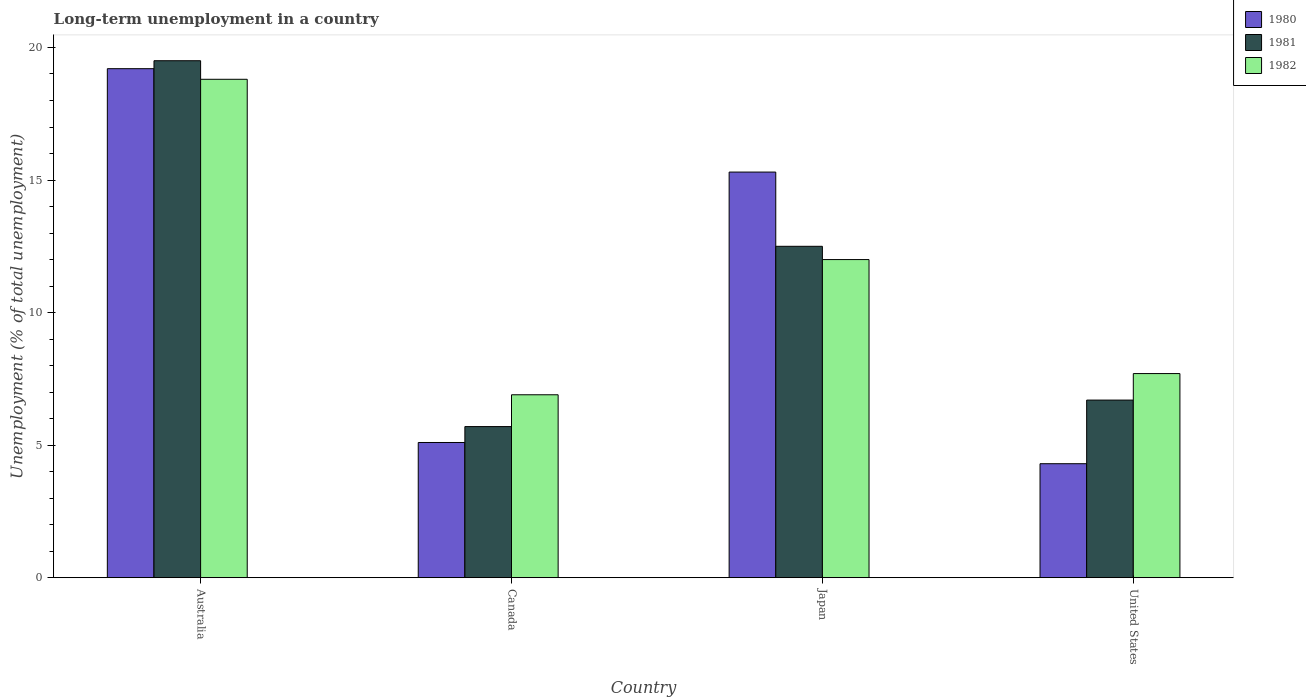How many groups of bars are there?
Your answer should be compact. 4. Are the number of bars on each tick of the X-axis equal?
Offer a terse response. Yes. How many bars are there on the 4th tick from the left?
Your answer should be compact. 3. What is the label of the 1st group of bars from the left?
Offer a terse response. Australia. In how many cases, is the number of bars for a given country not equal to the number of legend labels?
Your answer should be very brief. 0. What is the percentage of long-term unemployed population in 1981 in United States?
Provide a short and direct response. 6.7. Across all countries, what is the maximum percentage of long-term unemployed population in 1980?
Your answer should be compact. 19.2. Across all countries, what is the minimum percentage of long-term unemployed population in 1981?
Your answer should be compact. 5.7. In which country was the percentage of long-term unemployed population in 1981 maximum?
Your answer should be very brief. Australia. What is the total percentage of long-term unemployed population in 1981 in the graph?
Provide a succinct answer. 44.4. What is the difference between the percentage of long-term unemployed population in 1980 in Australia and that in Japan?
Offer a very short reply. 3.9. What is the difference between the percentage of long-term unemployed population in 1980 in United States and the percentage of long-term unemployed population in 1982 in Canada?
Your answer should be very brief. -2.6. What is the average percentage of long-term unemployed population in 1980 per country?
Offer a very short reply. 10.98. What is the difference between the percentage of long-term unemployed population of/in 1982 and percentage of long-term unemployed population of/in 1980 in Japan?
Your answer should be very brief. -3.3. What is the ratio of the percentage of long-term unemployed population in 1981 in Canada to that in Japan?
Provide a short and direct response. 0.46. Is the percentage of long-term unemployed population in 1980 in Australia less than that in Canada?
Your response must be concise. No. Is the difference between the percentage of long-term unemployed population in 1982 in Canada and Japan greater than the difference between the percentage of long-term unemployed population in 1980 in Canada and Japan?
Provide a succinct answer. Yes. What is the difference between the highest and the lowest percentage of long-term unemployed population in 1982?
Your answer should be very brief. 11.9. Is the sum of the percentage of long-term unemployed population in 1981 in Australia and United States greater than the maximum percentage of long-term unemployed population in 1980 across all countries?
Give a very brief answer. Yes. What does the 3rd bar from the left in Japan represents?
Provide a short and direct response. 1982. Is it the case that in every country, the sum of the percentage of long-term unemployed population in 1982 and percentage of long-term unemployed population in 1981 is greater than the percentage of long-term unemployed population in 1980?
Your response must be concise. Yes. What is the difference between two consecutive major ticks on the Y-axis?
Offer a terse response. 5. Are the values on the major ticks of Y-axis written in scientific E-notation?
Your answer should be compact. No. Does the graph contain any zero values?
Provide a succinct answer. No. Where does the legend appear in the graph?
Your answer should be very brief. Top right. How many legend labels are there?
Make the answer very short. 3. How are the legend labels stacked?
Your answer should be compact. Vertical. What is the title of the graph?
Offer a very short reply. Long-term unemployment in a country. Does "1973" appear as one of the legend labels in the graph?
Your answer should be compact. No. What is the label or title of the Y-axis?
Provide a succinct answer. Unemployment (% of total unemployment). What is the Unemployment (% of total unemployment) of 1980 in Australia?
Keep it short and to the point. 19.2. What is the Unemployment (% of total unemployment) of 1982 in Australia?
Your answer should be compact. 18.8. What is the Unemployment (% of total unemployment) of 1980 in Canada?
Give a very brief answer. 5.1. What is the Unemployment (% of total unemployment) of 1981 in Canada?
Keep it short and to the point. 5.7. What is the Unemployment (% of total unemployment) in 1982 in Canada?
Your answer should be very brief. 6.9. What is the Unemployment (% of total unemployment) of 1980 in Japan?
Your answer should be compact. 15.3. What is the Unemployment (% of total unemployment) in 1980 in United States?
Your answer should be compact. 4.3. What is the Unemployment (% of total unemployment) of 1981 in United States?
Provide a succinct answer. 6.7. What is the Unemployment (% of total unemployment) in 1982 in United States?
Offer a terse response. 7.7. Across all countries, what is the maximum Unemployment (% of total unemployment) in 1980?
Keep it short and to the point. 19.2. Across all countries, what is the maximum Unemployment (% of total unemployment) of 1981?
Your answer should be very brief. 19.5. Across all countries, what is the maximum Unemployment (% of total unemployment) of 1982?
Provide a succinct answer. 18.8. Across all countries, what is the minimum Unemployment (% of total unemployment) of 1980?
Make the answer very short. 4.3. Across all countries, what is the minimum Unemployment (% of total unemployment) in 1981?
Offer a terse response. 5.7. Across all countries, what is the minimum Unemployment (% of total unemployment) in 1982?
Make the answer very short. 6.9. What is the total Unemployment (% of total unemployment) in 1980 in the graph?
Give a very brief answer. 43.9. What is the total Unemployment (% of total unemployment) in 1981 in the graph?
Offer a very short reply. 44.4. What is the total Unemployment (% of total unemployment) in 1982 in the graph?
Provide a short and direct response. 45.4. What is the difference between the Unemployment (% of total unemployment) of 1980 in Australia and that in Canada?
Offer a terse response. 14.1. What is the difference between the Unemployment (% of total unemployment) of 1981 in Australia and that in Canada?
Offer a terse response. 13.8. What is the difference between the Unemployment (% of total unemployment) in 1981 in Australia and that in Japan?
Offer a terse response. 7. What is the difference between the Unemployment (% of total unemployment) in 1980 in Australia and that in United States?
Provide a short and direct response. 14.9. What is the difference between the Unemployment (% of total unemployment) in 1980 in Canada and that in Japan?
Make the answer very short. -10.2. What is the difference between the Unemployment (% of total unemployment) of 1982 in Canada and that in Japan?
Your answer should be compact. -5.1. What is the difference between the Unemployment (% of total unemployment) in 1981 in Canada and that in United States?
Provide a short and direct response. -1. What is the difference between the Unemployment (% of total unemployment) of 1981 in Japan and that in United States?
Ensure brevity in your answer.  5.8. What is the difference between the Unemployment (% of total unemployment) in 1980 in Australia and the Unemployment (% of total unemployment) in 1981 in Canada?
Your response must be concise. 13.5. What is the difference between the Unemployment (% of total unemployment) in 1980 in Australia and the Unemployment (% of total unemployment) in 1982 in Canada?
Offer a terse response. 12.3. What is the difference between the Unemployment (% of total unemployment) of 1980 in Australia and the Unemployment (% of total unemployment) of 1982 in Japan?
Keep it short and to the point. 7.2. What is the difference between the Unemployment (% of total unemployment) of 1980 in Australia and the Unemployment (% of total unemployment) of 1981 in United States?
Offer a terse response. 12.5. What is the difference between the Unemployment (% of total unemployment) of 1980 in Australia and the Unemployment (% of total unemployment) of 1982 in United States?
Keep it short and to the point. 11.5. What is the difference between the Unemployment (% of total unemployment) of 1981 in Australia and the Unemployment (% of total unemployment) of 1982 in United States?
Your answer should be compact. 11.8. What is the difference between the Unemployment (% of total unemployment) in 1981 in Canada and the Unemployment (% of total unemployment) in 1982 in Japan?
Ensure brevity in your answer.  -6.3. What is the difference between the Unemployment (% of total unemployment) of 1980 in Canada and the Unemployment (% of total unemployment) of 1981 in United States?
Ensure brevity in your answer.  -1.6. What is the difference between the Unemployment (% of total unemployment) of 1980 in Japan and the Unemployment (% of total unemployment) of 1981 in United States?
Your answer should be compact. 8.6. What is the difference between the Unemployment (% of total unemployment) of 1980 in Japan and the Unemployment (% of total unemployment) of 1982 in United States?
Ensure brevity in your answer.  7.6. What is the difference between the Unemployment (% of total unemployment) of 1981 in Japan and the Unemployment (% of total unemployment) of 1982 in United States?
Your answer should be compact. 4.8. What is the average Unemployment (% of total unemployment) of 1980 per country?
Ensure brevity in your answer.  10.97. What is the average Unemployment (% of total unemployment) in 1981 per country?
Provide a succinct answer. 11.1. What is the average Unemployment (% of total unemployment) in 1982 per country?
Your answer should be very brief. 11.35. What is the difference between the Unemployment (% of total unemployment) of 1980 and Unemployment (% of total unemployment) of 1981 in Australia?
Keep it short and to the point. -0.3. What is the difference between the Unemployment (% of total unemployment) of 1980 and Unemployment (% of total unemployment) of 1981 in Canada?
Ensure brevity in your answer.  -0.6. What is the difference between the Unemployment (% of total unemployment) in 1981 and Unemployment (% of total unemployment) in 1982 in Canada?
Make the answer very short. -1.2. What is the difference between the Unemployment (% of total unemployment) in 1980 and Unemployment (% of total unemployment) in 1981 in Japan?
Offer a very short reply. 2.8. What is the difference between the Unemployment (% of total unemployment) in 1980 and Unemployment (% of total unemployment) in 1982 in Japan?
Offer a very short reply. 3.3. What is the difference between the Unemployment (% of total unemployment) of 1980 and Unemployment (% of total unemployment) of 1982 in United States?
Keep it short and to the point. -3.4. What is the difference between the Unemployment (% of total unemployment) in 1981 and Unemployment (% of total unemployment) in 1982 in United States?
Provide a short and direct response. -1. What is the ratio of the Unemployment (% of total unemployment) in 1980 in Australia to that in Canada?
Make the answer very short. 3.76. What is the ratio of the Unemployment (% of total unemployment) in 1981 in Australia to that in Canada?
Your answer should be compact. 3.42. What is the ratio of the Unemployment (% of total unemployment) of 1982 in Australia to that in Canada?
Give a very brief answer. 2.72. What is the ratio of the Unemployment (% of total unemployment) in 1980 in Australia to that in Japan?
Ensure brevity in your answer.  1.25. What is the ratio of the Unemployment (% of total unemployment) in 1981 in Australia to that in Japan?
Offer a very short reply. 1.56. What is the ratio of the Unemployment (% of total unemployment) in 1982 in Australia to that in Japan?
Your answer should be very brief. 1.57. What is the ratio of the Unemployment (% of total unemployment) in 1980 in Australia to that in United States?
Your response must be concise. 4.47. What is the ratio of the Unemployment (% of total unemployment) in 1981 in Australia to that in United States?
Ensure brevity in your answer.  2.91. What is the ratio of the Unemployment (% of total unemployment) of 1982 in Australia to that in United States?
Offer a very short reply. 2.44. What is the ratio of the Unemployment (% of total unemployment) in 1980 in Canada to that in Japan?
Provide a succinct answer. 0.33. What is the ratio of the Unemployment (% of total unemployment) of 1981 in Canada to that in Japan?
Ensure brevity in your answer.  0.46. What is the ratio of the Unemployment (% of total unemployment) in 1982 in Canada to that in Japan?
Offer a very short reply. 0.57. What is the ratio of the Unemployment (% of total unemployment) of 1980 in Canada to that in United States?
Keep it short and to the point. 1.19. What is the ratio of the Unemployment (% of total unemployment) of 1981 in Canada to that in United States?
Keep it short and to the point. 0.85. What is the ratio of the Unemployment (% of total unemployment) in 1982 in Canada to that in United States?
Keep it short and to the point. 0.9. What is the ratio of the Unemployment (% of total unemployment) in 1980 in Japan to that in United States?
Provide a short and direct response. 3.56. What is the ratio of the Unemployment (% of total unemployment) of 1981 in Japan to that in United States?
Your answer should be compact. 1.87. What is the ratio of the Unemployment (% of total unemployment) of 1982 in Japan to that in United States?
Keep it short and to the point. 1.56. What is the difference between the highest and the second highest Unemployment (% of total unemployment) of 1980?
Offer a terse response. 3.9. What is the difference between the highest and the second highest Unemployment (% of total unemployment) of 1982?
Give a very brief answer. 6.8. 